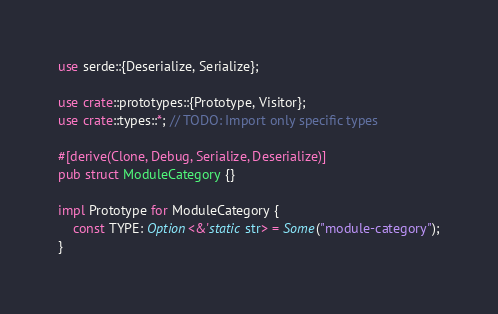<code> <loc_0><loc_0><loc_500><loc_500><_Rust_>use serde::{Deserialize, Serialize};

use crate::prototypes::{Prototype, Visitor};
use crate::types::*; // TODO: Import only specific types

#[derive(Clone, Debug, Serialize, Deserialize)]
pub struct ModuleCategory {}

impl Prototype for ModuleCategory {
    const TYPE: Option<&'static str> = Some("module-category");
}
</code> 